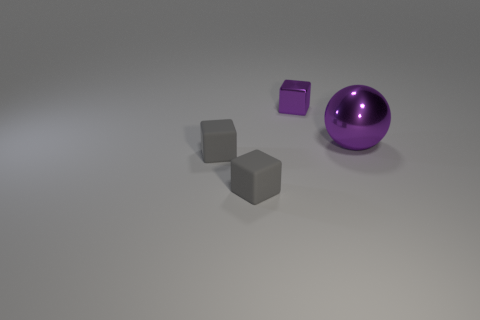Is there anything else that is the same size as the purple metal ball?
Your answer should be compact. No. What color is the metal object to the left of the ball?
Give a very brief answer. Purple. Is there another small rubber object of the same shape as the tiny purple thing?
Keep it short and to the point. Yes. Is the number of blocks in front of the purple cube less than the number of things to the left of the big purple metallic thing?
Provide a short and direct response. Yes. The tiny shiny thing has what color?
Provide a succinct answer. Purple. Is there a big purple metallic object left of the purple object that is in front of the tiny metallic cube?
Make the answer very short. No. How many purple metal spheres have the same size as the purple cube?
Your answer should be compact. 0. What number of purple metal things are in front of the object that is behind the shiny object that is right of the tiny purple shiny cube?
Provide a succinct answer. 1. What number of objects are left of the metallic ball and in front of the small purple shiny block?
Your answer should be very brief. 2. How many matte things are small things or purple things?
Offer a terse response. 2. 